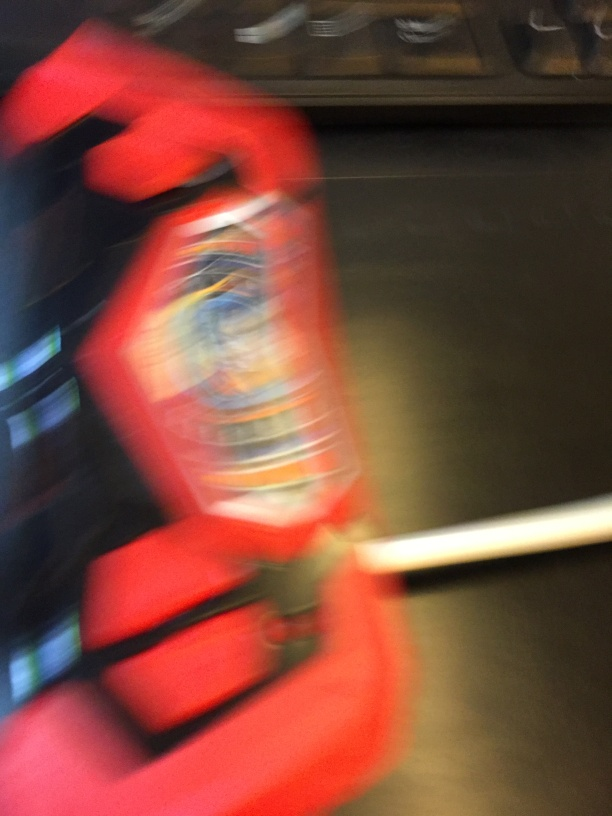What recommendations would you give to improve the sharpness of this image? To improve sharpness, one could use a faster shutter speed to minimize motion blur, ensure the camera is stable, possibly by using a tripod, and employ a higher ISO setting in low light. Additionally, focusing techniques such as manual focus or autofocus points selection can be crucial for a clear shot. 